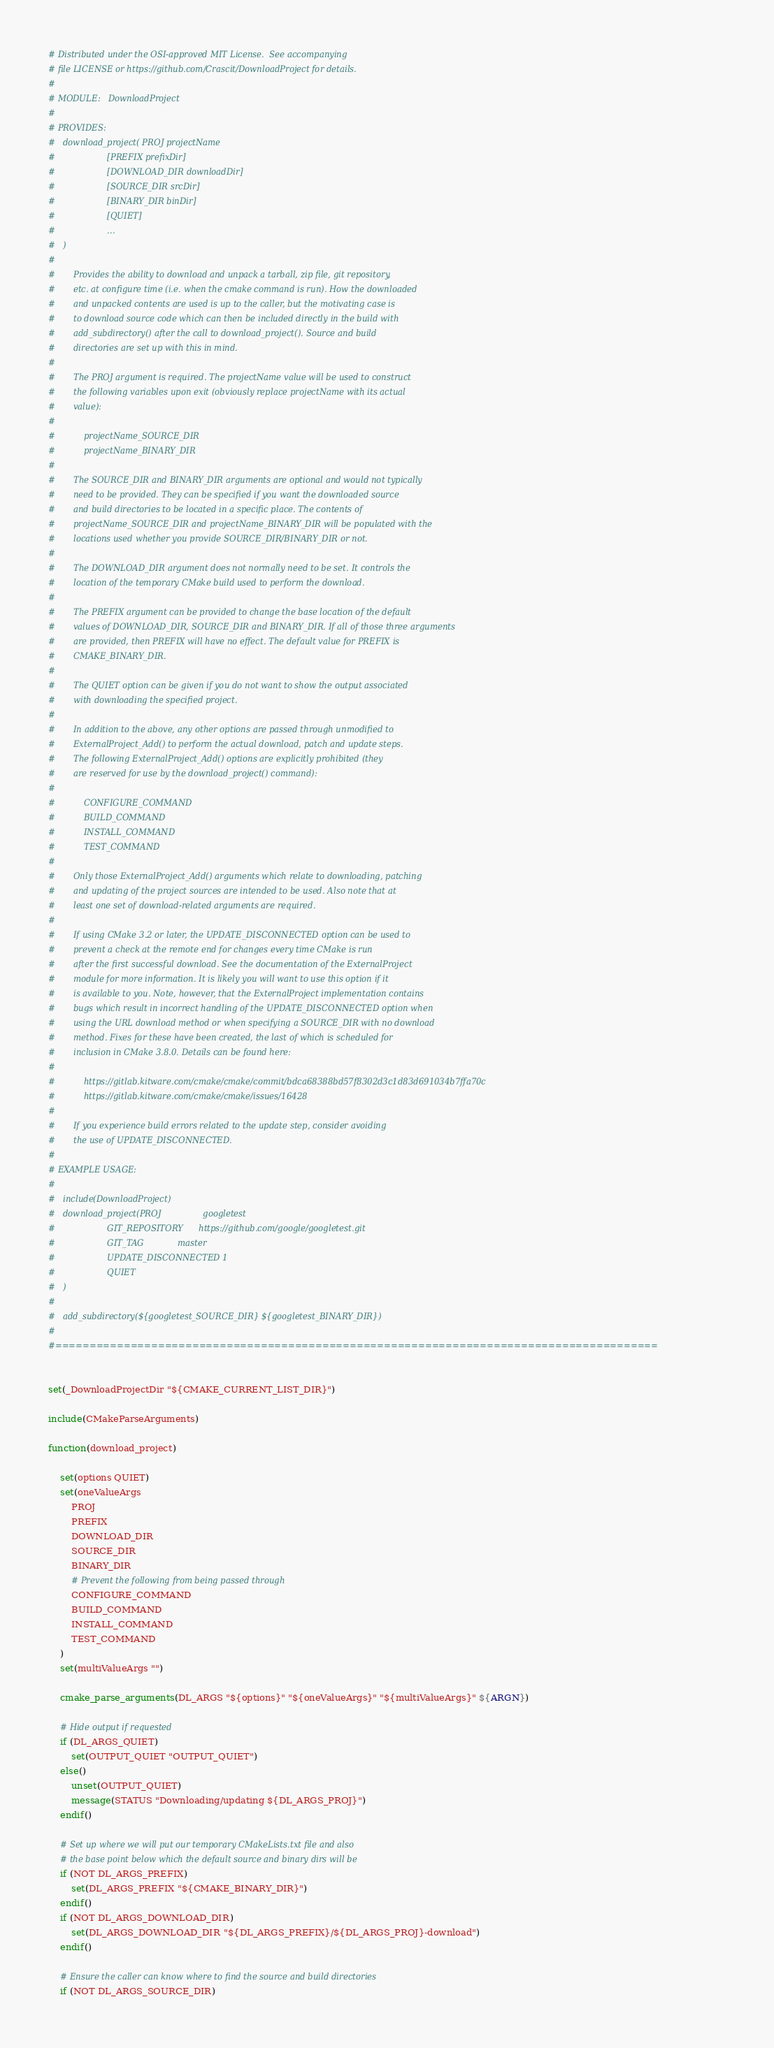Convert code to text. <code><loc_0><loc_0><loc_500><loc_500><_CMake_># Distributed under the OSI-approved MIT License.  See accompanying
# file LICENSE or https://github.com/Crascit/DownloadProject for details.
#
# MODULE:   DownloadProject
#
# PROVIDES:
#   download_project( PROJ projectName
#                    [PREFIX prefixDir]
#                    [DOWNLOAD_DIR downloadDir]
#                    [SOURCE_DIR srcDir]
#                    [BINARY_DIR binDir]
#                    [QUIET]
#                    ...
#   )
#
#       Provides the ability to download and unpack a tarball, zip file, git repository,
#       etc. at configure time (i.e. when the cmake command is run). How the downloaded
#       and unpacked contents are used is up to the caller, but the motivating case is
#       to download source code which can then be included directly in the build with
#       add_subdirectory() after the call to download_project(). Source and build
#       directories are set up with this in mind.
#
#       The PROJ argument is required. The projectName value will be used to construct
#       the following variables upon exit (obviously replace projectName with its actual
#       value):
#
#           projectName_SOURCE_DIR
#           projectName_BINARY_DIR
#
#       The SOURCE_DIR and BINARY_DIR arguments are optional and would not typically
#       need to be provided. They can be specified if you want the downloaded source
#       and build directories to be located in a specific place. The contents of
#       projectName_SOURCE_DIR and projectName_BINARY_DIR will be populated with the
#       locations used whether you provide SOURCE_DIR/BINARY_DIR or not.
#
#       The DOWNLOAD_DIR argument does not normally need to be set. It controls the
#       location of the temporary CMake build used to perform the download.
#
#       The PREFIX argument can be provided to change the base location of the default
#       values of DOWNLOAD_DIR, SOURCE_DIR and BINARY_DIR. If all of those three arguments
#       are provided, then PREFIX will have no effect. The default value for PREFIX is
#       CMAKE_BINARY_DIR.
#
#       The QUIET option can be given if you do not want to show the output associated
#       with downloading the specified project.
#
#       In addition to the above, any other options are passed through unmodified to
#       ExternalProject_Add() to perform the actual download, patch and update steps.
#       The following ExternalProject_Add() options are explicitly prohibited (they
#       are reserved for use by the download_project() command):
#
#           CONFIGURE_COMMAND
#           BUILD_COMMAND
#           INSTALL_COMMAND
#           TEST_COMMAND
#
#       Only those ExternalProject_Add() arguments which relate to downloading, patching
#       and updating of the project sources are intended to be used. Also note that at
#       least one set of download-related arguments are required.
#
#       If using CMake 3.2 or later, the UPDATE_DISCONNECTED option can be used to
#       prevent a check at the remote end for changes every time CMake is run
#       after the first successful download. See the documentation of the ExternalProject
#       module for more information. It is likely you will want to use this option if it
#       is available to you. Note, however, that the ExternalProject implementation contains
#       bugs which result in incorrect handling of the UPDATE_DISCONNECTED option when
#       using the URL download method or when specifying a SOURCE_DIR with no download
#       method. Fixes for these have been created, the last of which is scheduled for
#       inclusion in CMake 3.8.0. Details can be found here:
#
#           https://gitlab.kitware.com/cmake/cmake/commit/bdca68388bd57f8302d3c1d83d691034b7ffa70c
#           https://gitlab.kitware.com/cmake/cmake/issues/16428
#
#       If you experience build errors related to the update step, consider avoiding
#       the use of UPDATE_DISCONNECTED.
#
# EXAMPLE USAGE:
#
#   include(DownloadProject)
#   download_project(PROJ                googletest
#                    GIT_REPOSITORY      https://github.com/google/googletest.git
#                    GIT_TAG             master
#                    UPDATE_DISCONNECTED 1
#                    QUIET
#   )
#
#   add_subdirectory(${googletest_SOURCE_DIR} ${googletest_BINARY_DIR})
#
#========================================================================================


set(_DownloadProjectDir "${CMAKE_CURRENT_LIST_DIR}")

include(CMakeParseArguments)

function(download_project)

    set(options QUIET)
    set(oneValueArgs
        PROJ
        PREFIX
        DOWNLOAD_DIR
        SOURCE_DIR
        BINARY_DIR
        # Prevent the following from being passed through
        CONFIGURE_COMMAND
        BUILD_COMMAND
        INSTALL_COMMAND
        TEST_COMMAND
    )
    set(multiValueArgs "")

    cmake_parse_arguments(DL_ARGS "${options}" "${oneValueArgs}" "${multiValueArgs}" ${ARGN})

    # Hide output if requested
    if (DL_ARGS_QUIET)
        set(OUTPUT_QUIET "OUTPUT_QUIET")
    else()
        unset(OUTPUT_QUIET)
        message(STATUS "Downloading/updating ${DL_ARGS_PROJ}")
    endif()

    # Set up where we will put our temporary CMakeLists.txt file and also
    # the base point below which the default source and binary dirs will be
    if (NOT DL_ARGS_PREFIX)
        set(DL_ARGS_PREFIX "${CMAKE_BINARY_DIR}")
    endif()
    if (NOT DL_ARGS_DOWNLOAD_DIR)
        set(DL_ARGS_DOWNLOAD_DIR "${DL_ARGS_PREFIX}/${DL_ARGS_PROJ}-download")
    endif()

    # Ensure the caller can know where to find the source and build directories
    if (NOT DL_ARGS_SOURCE_DIR)</code> 